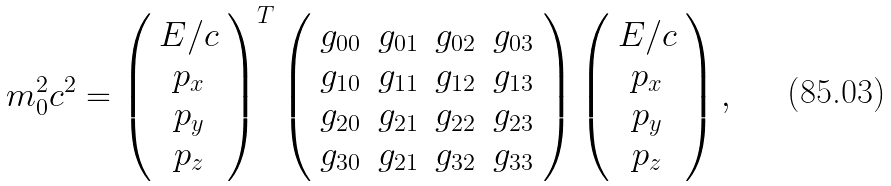Convert formula to latex. <formula><loc_0><loc_0><loc_500><loc_500>m _ { 0 } ^ { 2 } c ^ { 2 } = \left ( \begin{array} { c } E / c \\ p _ { x } \\ p _ { y } \\ p _ { z } \end{array} \right ) ^ { T } \left ( \begin{array} { c c c c } g _ { 0 0 } & g _ { 0 1 } & g _ { 0 2 } & g _ { 0 3 } \\ g _ { 1 0 } & g _ { 1 1 } & g _ { 1 2 } & g _ { 1 3 } \\ g _ { 2 0 } & g _ { 2 1 } & g _ { 2 2 } & g _ { 2 3 } \\ g _ { 3 0 } & g _ { 2 1 } & g _ { 3 2 } & g _ { 3 3 } \end{array} \right ) \left ( \begin{array} { c } E / c \\ p _ { x } \\ p _ { y } \\ p _ { z } \end{array} \right ) ,</formula> 